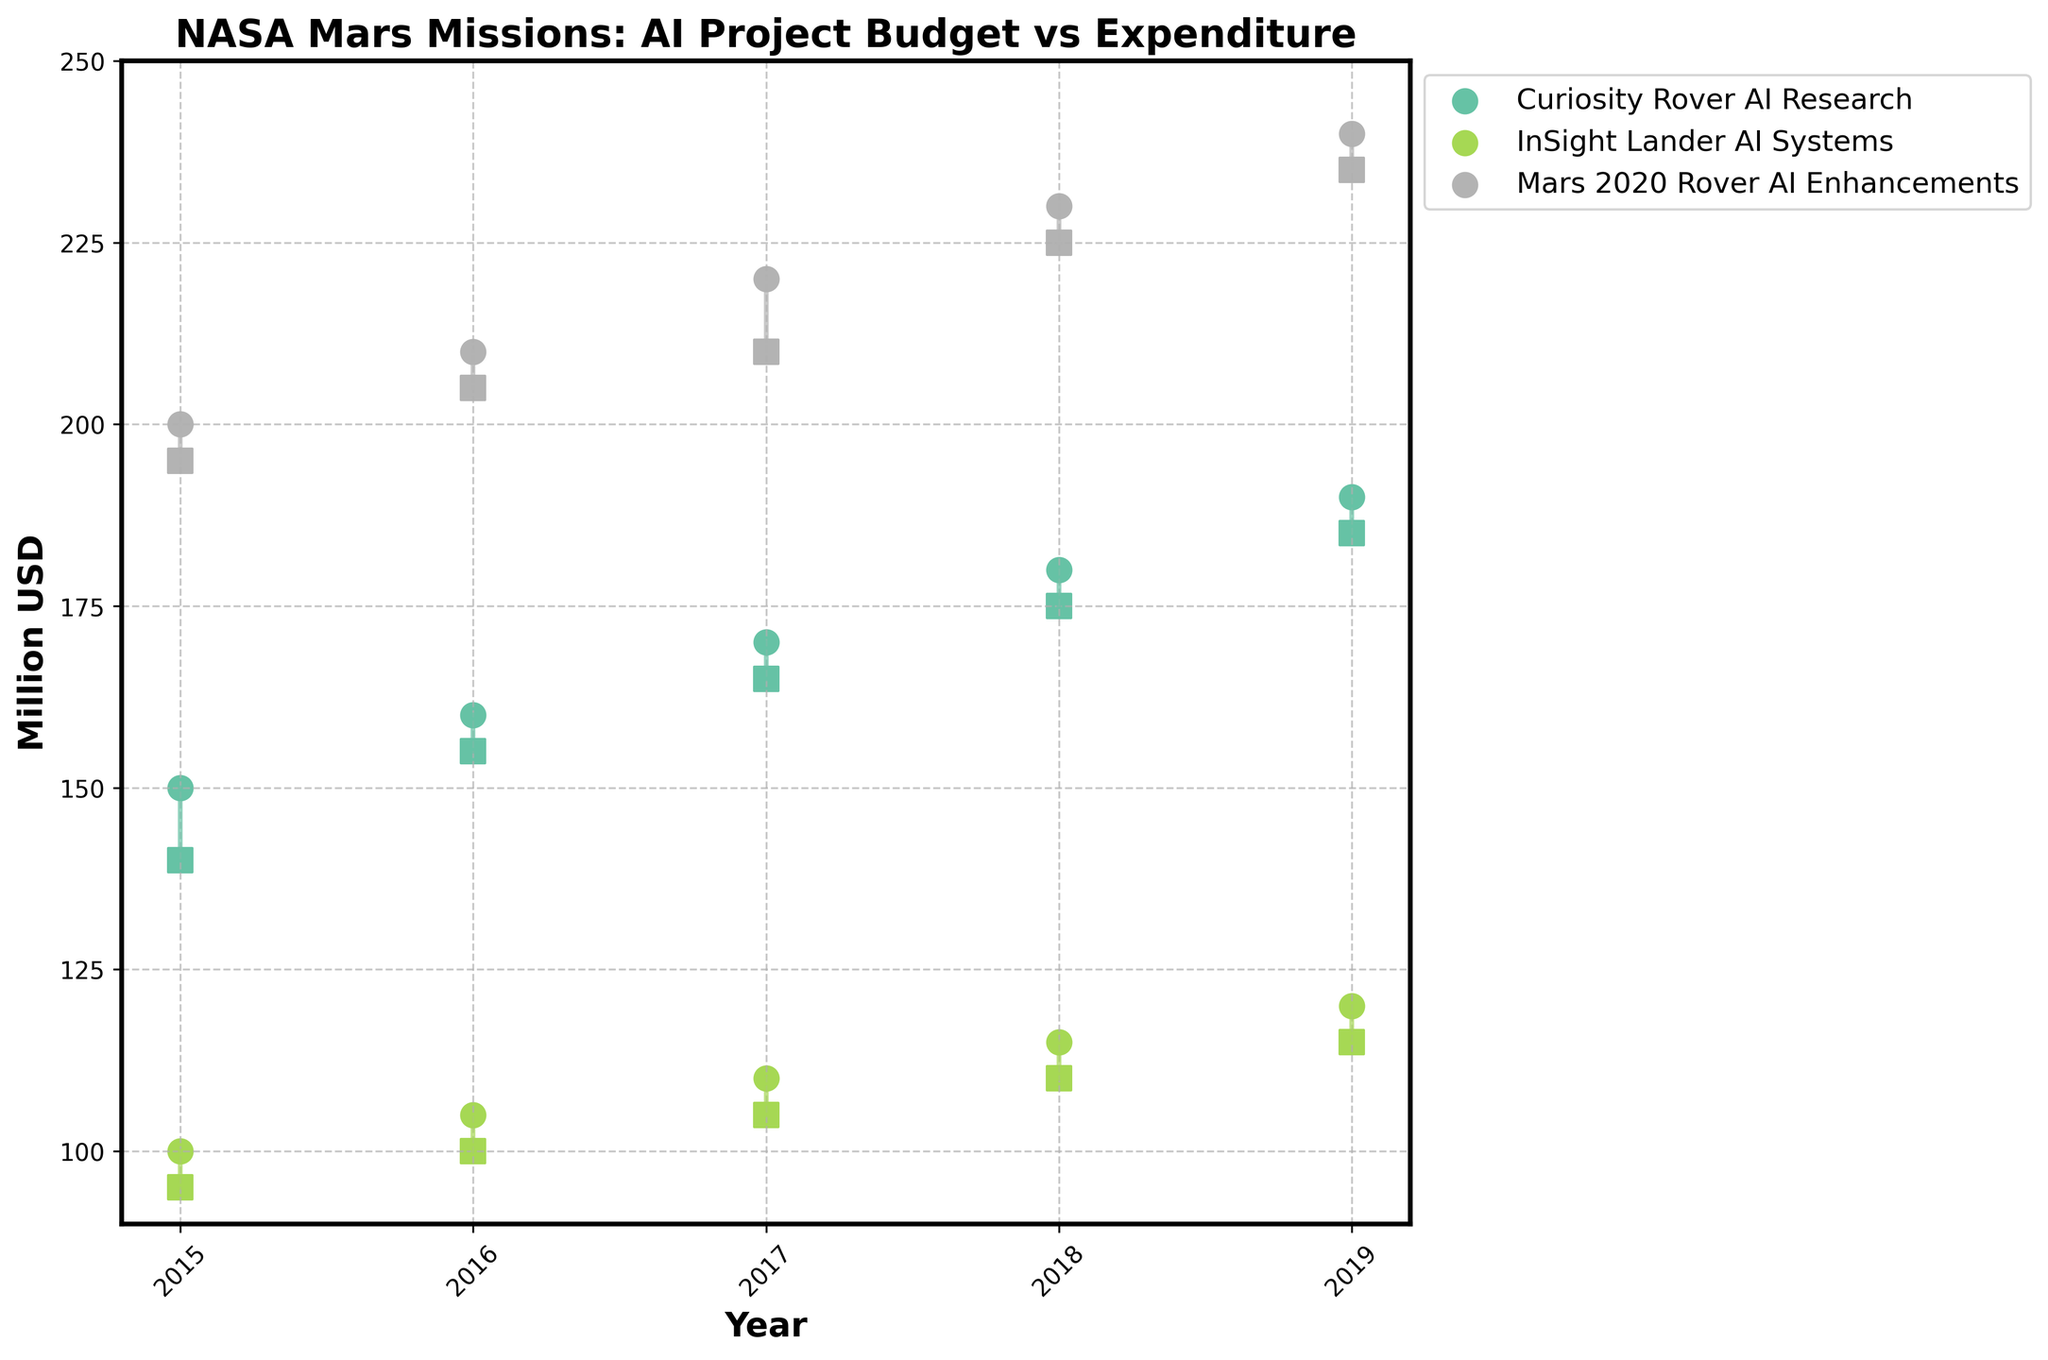What is the title of the plot? The title is located at the top of the plot, indicating the main subject of the figure.
Answer: 'NASA Mars Missions: AI Project Budget vs Expenditure' What years are covered in this data set? The x-axis of the plot, representing years, shows the range of years included.
Answer: 2015 to 2019 Which project had the largest budget allocation in 2019? The marker indicating the budget for each project in 2019 can be compared to identify the largest one.
Answer: Mars 2020 Rover AI Enhancements What is the approximate difference between the yearly budget allocation and the actual expenditure for the Curiosity Rover AI Research in 2017? Locate the markers for Curiosity Rover AI Research in 2017 and calculate the difference between the budget allocation and actual expenditure.
Answer: 5 million USD Which project consistently underspent relative to its budget over the years? By comparing the markers (circles for budget and squares for expenditure) for each project, we observe which one consistently has the square below the matching circle.
Answer: InSight Lander AI Systems In which year did the Mars 2020 Rover AI Enhancements have the smallest difference between its budget allocation and actual expenditure? Examine the vertical lines connecting the markers for each year of the Mars 2020 Rover AI Enhancements to identify the shortest line.
Answer: 2019 How does the actual expenditure in 2016 for InSight Lander AI Systems compare to its budget allocation? Look at the markers for 2016 for InSight Lander AI Systems and note the relative positions.
Answer: 5 million USD less Which project showed the highest increase in budget allocation from 2015 to 2019? By observing the connected markers, compare the vertical distances covered by each project from 2015 to 2019.
Answer: Mars 2020 Rover AI Enhancements What is the average actual expenditure for the Curiosity Rover AI Research from 2015 to 2019? Sum up the actual expenditures for each year (140 + 155 + 165 + 175 + 185) and divide by the number of years.
Answer: 164 million USD Do any projects have a year when the actual expenditure exceeded the budget allocation? For each year and project, check if any square marker (actual expenditure) is higher than the corresponding circle marker (budget allocation).
Answer: No 